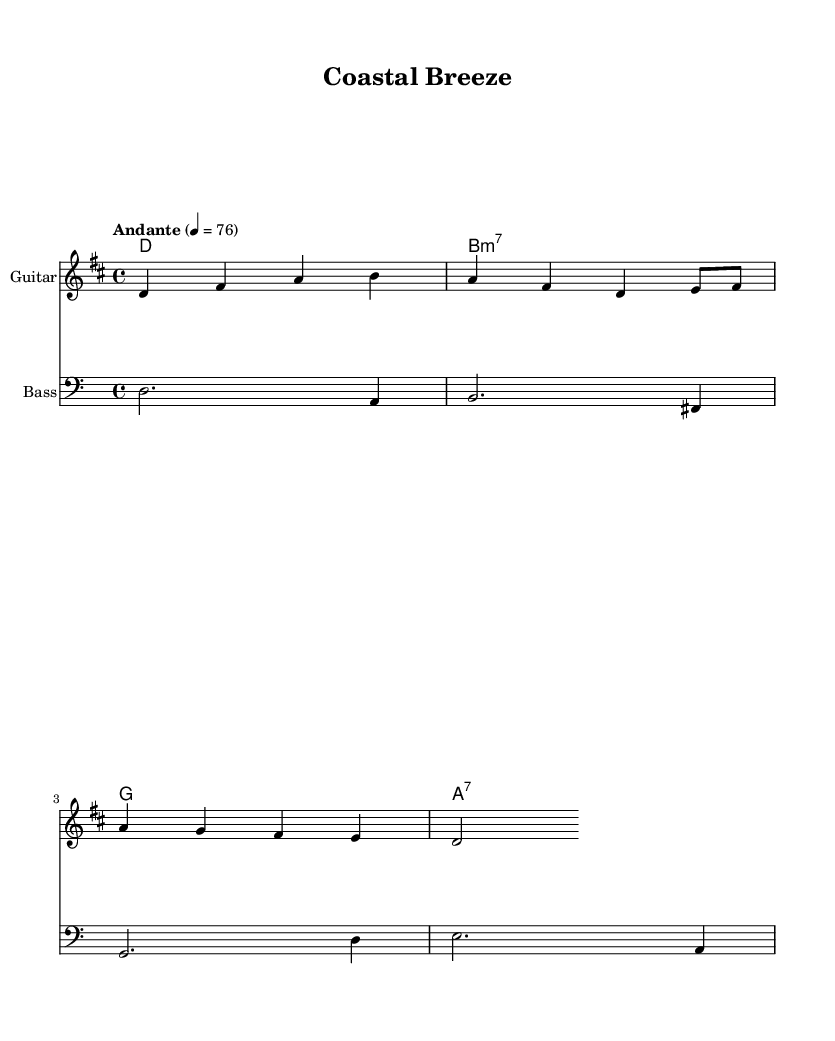What is the key signature of this music? The key signature is D major, which has two sharps: F sharp and C sharp. This can be identified from the key signature notation at the beginning of the sheet music, showing the two sharps.
Answer: D major What is the time signature of the piece? The time signature is 4/4, which indicates that there are four beats in each measure and the quarter note receives one beat. This is noted at the beginning of the sheet music right after the key signature.
Answer: 4/4 What is the tempo marking of the piece? The tempo marking states "Andante" with a metronome marking of 76, indicating a moderately slow pace. This information can be found just after the time signature in the score.
Answer: Andante 76 What instruments are included in this score? The score includes a Guitar and a Bass. This is visible under each staff heading, where the instrument names are clearly labeled.
Answer: Guitar and Bass Which chord is played during the first measure of the harmony? The first chord in the harmony is D major, indicated by the chord symbol at the beginning of the score. In music notation, this is usually represented at the start of the corresponding measure.
Answer: D What is the rhythm of the melody in the first measure? The rhythm of the melody in the first measure consists of four quarter notes: D, F sharp, A, and B. Each of these notes is held for one beat, as shown in the melodic notation.
Answer: Four quarter notes Which note appears at the end of the melody? The last note in the melody is D, which is a half note and is held for two beats as indicated at the end of the melodic staff.
Answer: D 